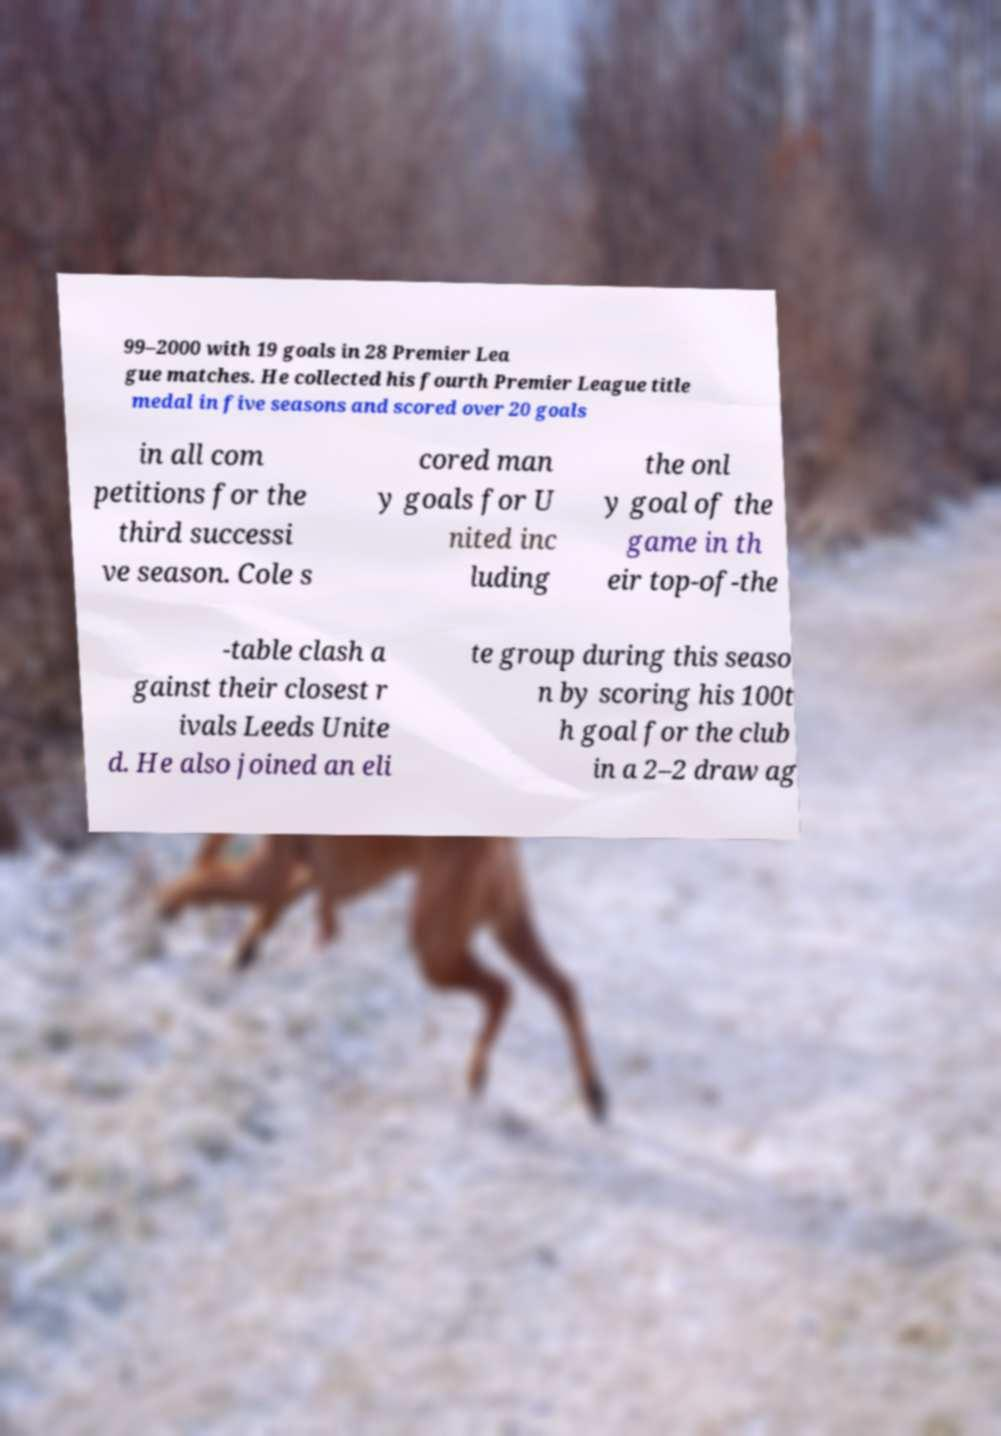What messages or text are displayed in this image? I need them in a readable, typed format. 99–2000 with 19 goals in 28 Premier Lea gue matches. He collected his fourth Premier League title medal in five seasons and scored over 20 goals in all com petitions for the third successi ve season. Cole s cored man y goals for U nited inc luding the onl y goal of the game in th eir top-of-the -table clash a gainst their closest r ivals Leeds Unite d. He also joined an eli te group during this seaso n by scoring his 100t h goal for the club in a 2–2 draw ag 